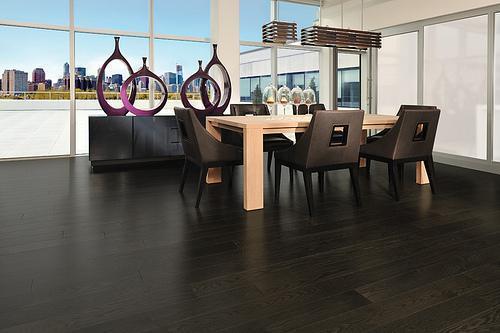How many vases are taller than the others?
Give a very brief answer. 2. 